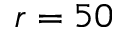Convert formula to latex. <formula><loc_0><loc_0><loc_500><loc_500>r = 5 0</formula> 